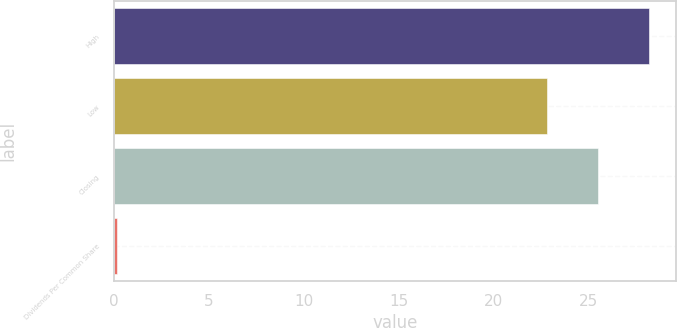<chart> <loc_0><loc_0><loc_500><loc_500><bar_chart><fcel>High<fcel>Low<fcel>Closing<fcel>Dividends Per Common Share<nl><fcel>28.19<fcel>22.83<fcel>25.51<fcel>0.14<nl></chart> 